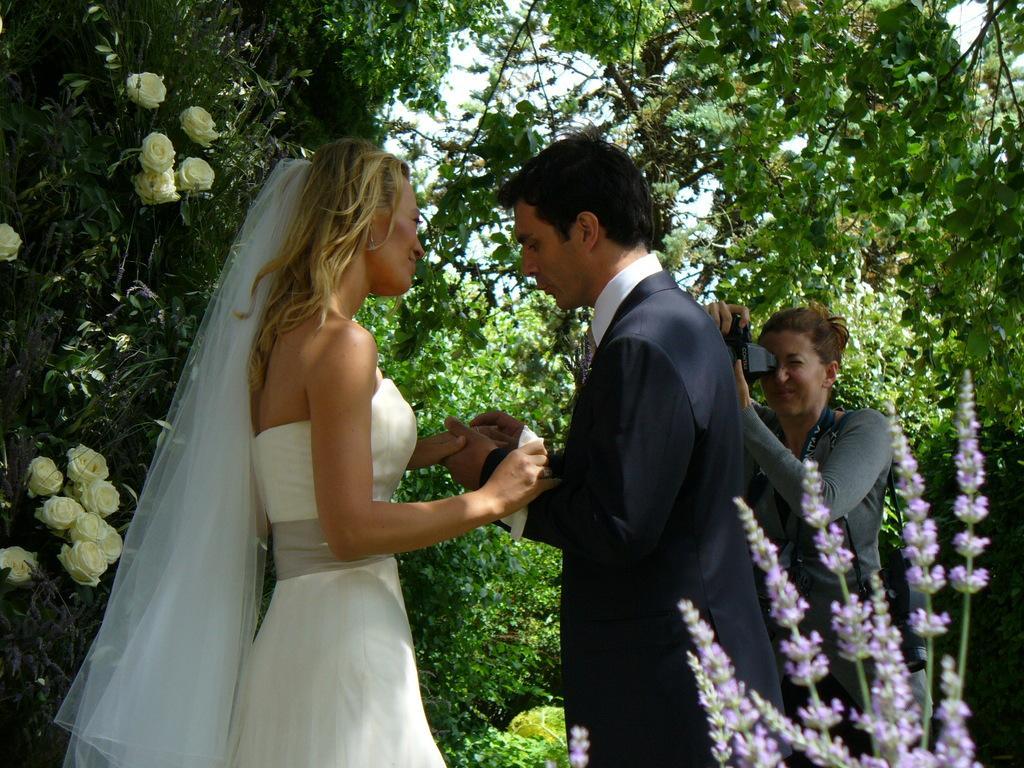Can you describe this image briefly? In this image I can see a woman wearing white colored dress and a man wearing white and black colored dress are standing and holding hands. I can see few trees which are green in color, few flowers which are cream and purple in color and a person holding a camera in hands. In the background I can see the sky. 